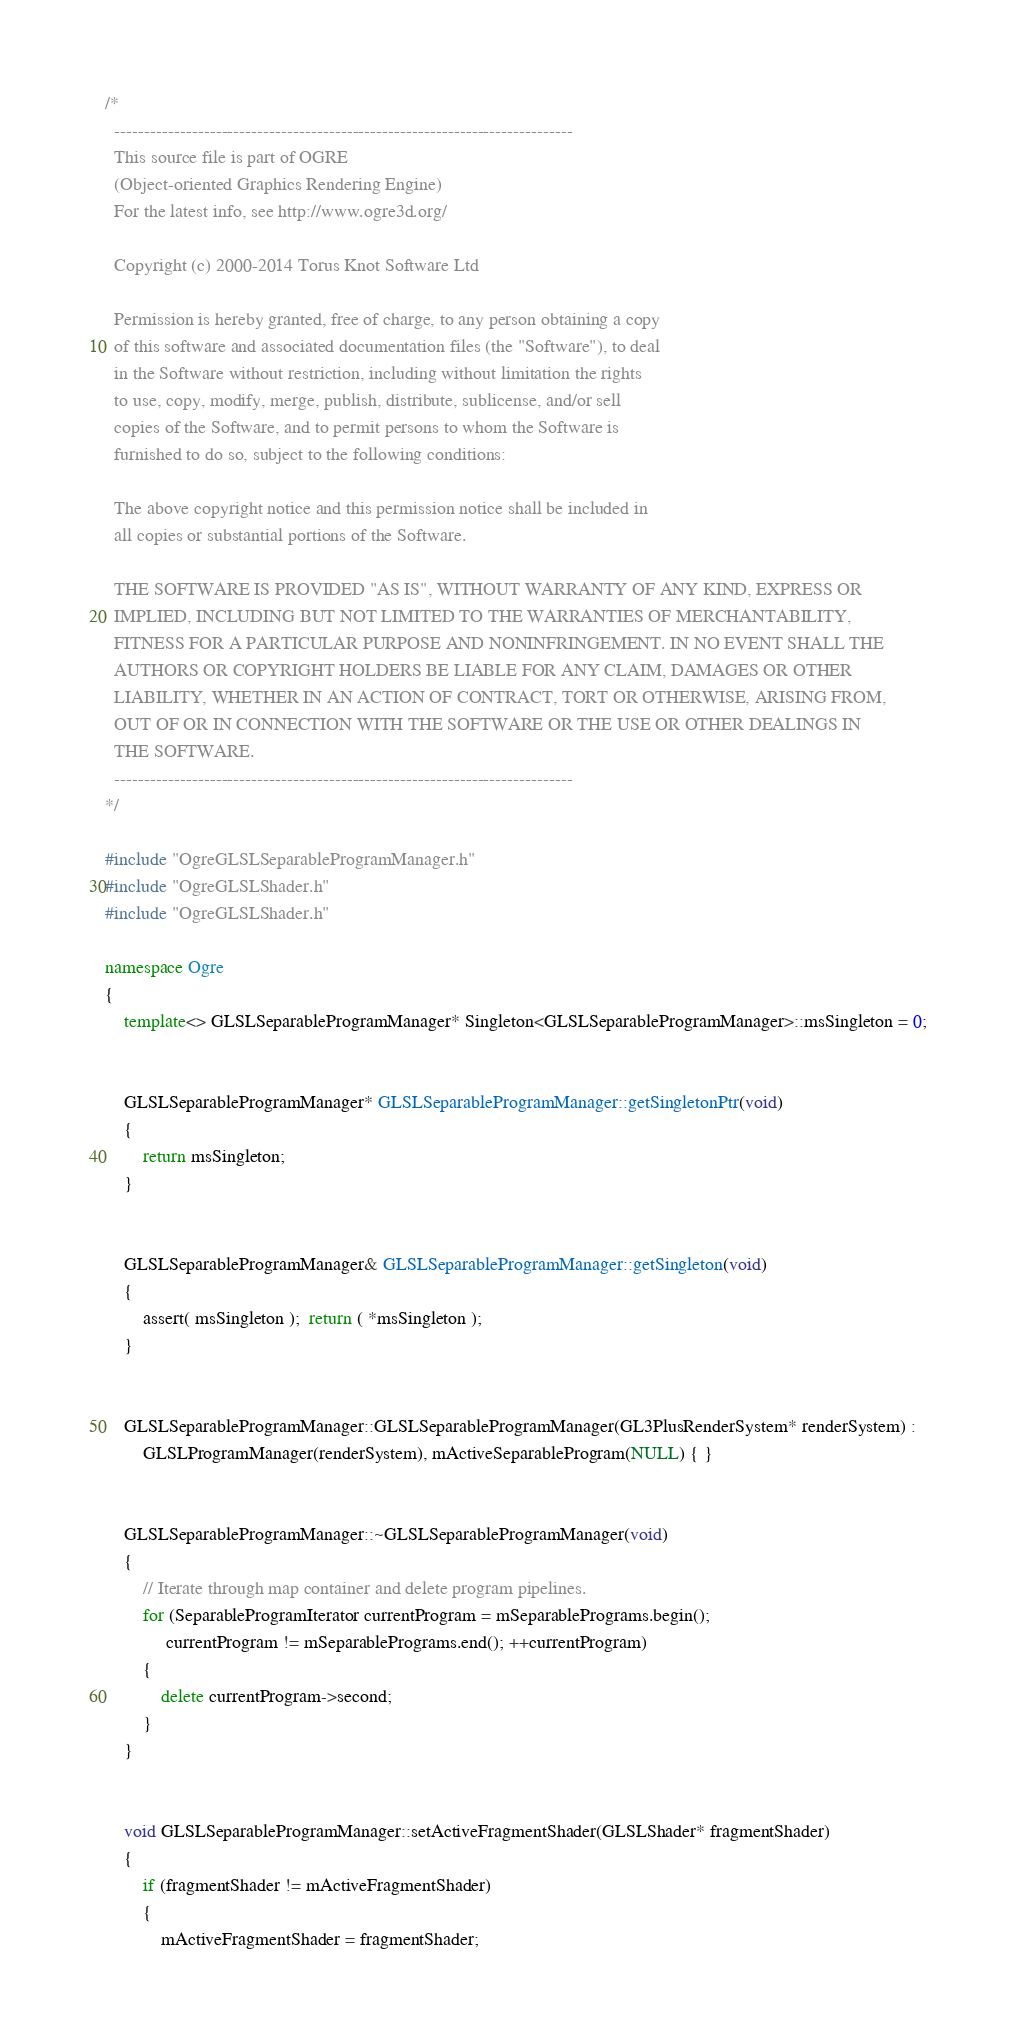Convert code to text. <code><loc_0><loc_0><loc_500><loc_500><_C++_>/*
  -----------------------------------------------------------------------------
  This source file is part of OGRE
  (Object-oriented Graphics Rendering Engine)
  For the latest info, see http://www.ogre3d.org/

  Copyright (c) 2000-2014 Torus Knot Software Ltd

  Permission is hereby granted, free of charge, to any person obtaining a copy
  of this software and associated documentation files (the "Software"), to deal
  in the Software without restriction, including without limitation the rights
  to use, copy, modify, merge, publish, distribute, sublicense, and/or sell
  copies of the Software, and to permit persons to whom the Software is
  furnished to do so, subject to the following conditions:

  The above copyright notice and this permission notice shall be included in
  all copies or substantial portions of the Software.

  THE SOFTWARE IS PROVIDED "AS IS", WITHOUT WARRANTY OF ANY KIND, EXPRESS OR
  IMPLIED, INCLUDING BUT NOT LIMITED TO THE WARRANTIES OF MERCHANTABILITY,
  FITNESS FOR A PARTICULAR PURPOSE AND NONINFRINGEMENT. IN NO EVENT SHALL THE
  AUTHORS OR COPYRIGHT HOLDERS BE LIABLE FOR ANY CLAIM, DAMAGES OR OTHER
  LIABILITY, WHETHER IN AN ACTION OF CONTRACT, TORT OR OTHERWISE, ARISING FROM,
  OUT OF OR IN CONNECTION WITH THE SOFTWARE OR THE USE OR OTHER DEALINGS IN
  THE SOFTWARE.
  -----------------------------------------------------------------------------
*/

#include "OgreGLSLSeparableProgramManager.h"
#include "OgreGLSLShader.h"
#include "OgreGLSLShader.h"

namespace Ogre
{
    template<> GLSLSeparableProgramManager* Singleton<GLSLSeparableProgramManager>::msSingleton = 0;


    GLSLSeparableProgramManager* GLSLSeparableProgramManager::getSingletonPtr(void)
    {
        return msSingleton;
    }


    GLSLSeparableProgramManager& GLSLSeparableProgramManager::getSingleton(void)
    {
        assert( msSingleton );  return ( *msSingleton );
    }


    GLSLSeparableProgramManager::GLSLSeparableProgramManager(GL3PlusRenderSystem* renderSystem) :
        GLSLProgramManager(renderSystem), mActiveSeparableProgram(NULL) { }


    GLSLSeparableProgramManager::~GLSLSeparableProgramManager(void)
    {
        // Iterate through map container and delete program pipelines.
        for (SeparableProgramIterator currentProgram = mSeparablePrograms.begin();
             currentProgram != mSeparablePrograms.end(); ++currentProgram)
        {
            delete currentProgram->second;
        }
    }


    void GLSLSeparableProgramManager::setActiveFragmentShader(GLSLShader* fragmentShader)
    {
        if (fragmentShader != mActiveFragmentShader)
        {
            mActiveFragmentShader = fragmentShader;</code> 